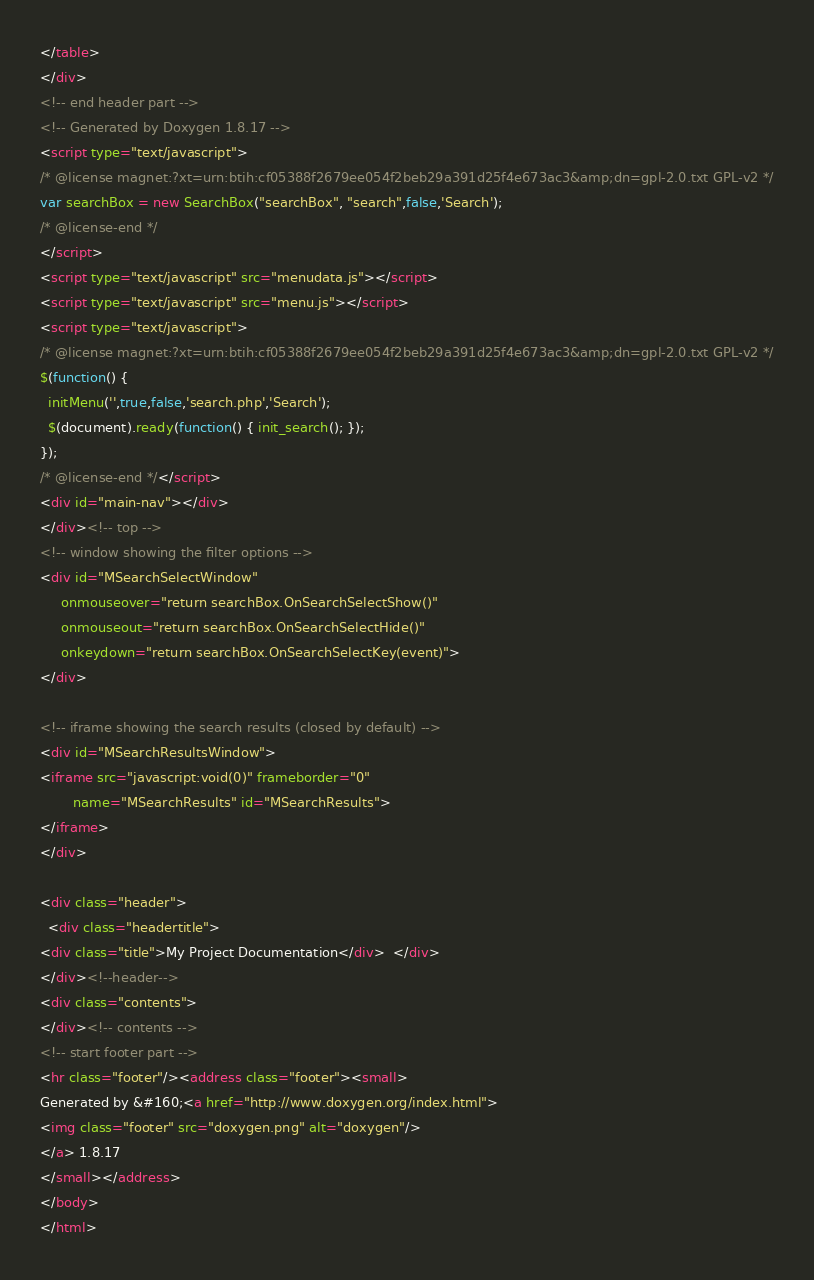<code> <loc_0><loc_0><loc_500><loc_500><_HTML_></table>
</div>
<!-- end header part -->
<!-- Generated by Doxygen 1.8.17 -->
<script type="text/javascript">
/* @license magnet:?xt=urn:btih:cf05388f2679ee054f2beb29a391d25f4e673ac3&amp;dn=gpl-2.0.txt GPL-v2 */
var searchBox = new SearchBox("searchBox", "search",false,'Search');
/* @license-end */
</script>
<script type="text/javascript" src="menudata.js"></script>
<script type="text/javascript" src="menu.js"></script>
<script type="text/javascript">
/* @license magnet:?xt=urn:btih:cf05388f2679ee054f2beb29a391d25f4e673ac3&amp;dn=gpl-2.0.txt GPL-v2 */
$(function() {
  initMenu('',true,false,'search.php','Search');
  $(document).ready(function() { init_search(); });
});
/* @license-end */</script>
<div id="main-nav"></div>
</div><!-- top -->
<!-- window showing the filter options -->
<div id="MSearchSelectWindow"
     onmouseover="return searchBox.OnSearchSelectShow()"
     onmouseout="return searchBox.OnSearchSelectHide()"
     onkeydown="return searchBox.OnSearchSelectKey(event)">
</div>

<!-- iframe showing the search results (closed by default) -->
<div id="MSearchResultsWindow">
<iframe src="javascript:void(0)" frameborder="0" 
        name="MSearchResults" id="MSearchResults">
</iframe>
</div>

<div class="header">
  <div class="headertitle">
<div class="title">My Project Documentation</div>  </div>
</div><!--header-->
<div class="contents">
</div><!-- contents -->
<!-- start footer part -->
<hr class="footer"/><address class="footer"><small>
Generated by &#160;<a href="http://www.doxygen.org/index.html">
<img class="footer" src="doxygen.png" alt="doxygen"/>
</a> 1.8.17
</small></address>
</body>
</html>
</code> 